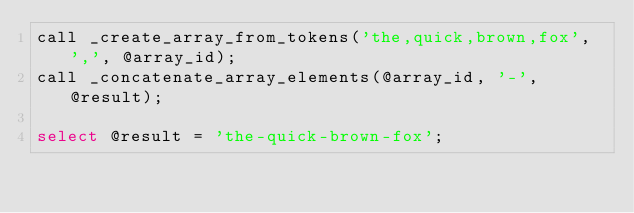<code> <loc_0><loc_0><loc_500><loc_500><_SQL_>call _create_array_from_tokens('the,quick,brown,fox', ',', @array_id);
call _concatenate_array_elements(@array_id, '-', @result);

select @result = 'the-quick-brown-fox';

</code> 